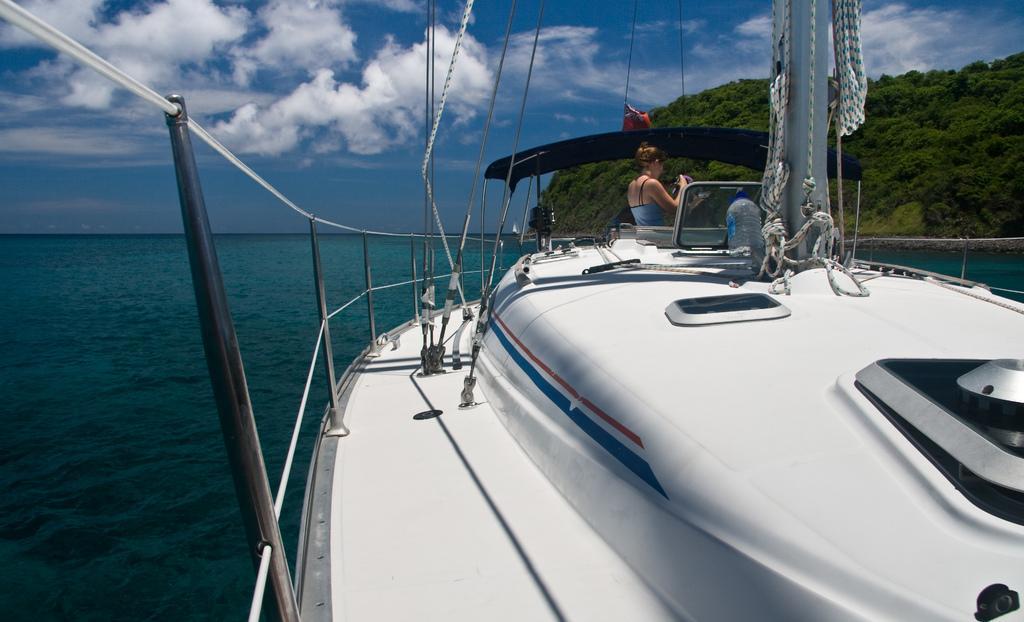Can you describe this image briefly? There is a ship and a woman standing in the front of the ship,the ship is sailing in the water and beside the water there is a mountain covered with a lot of greenery. 